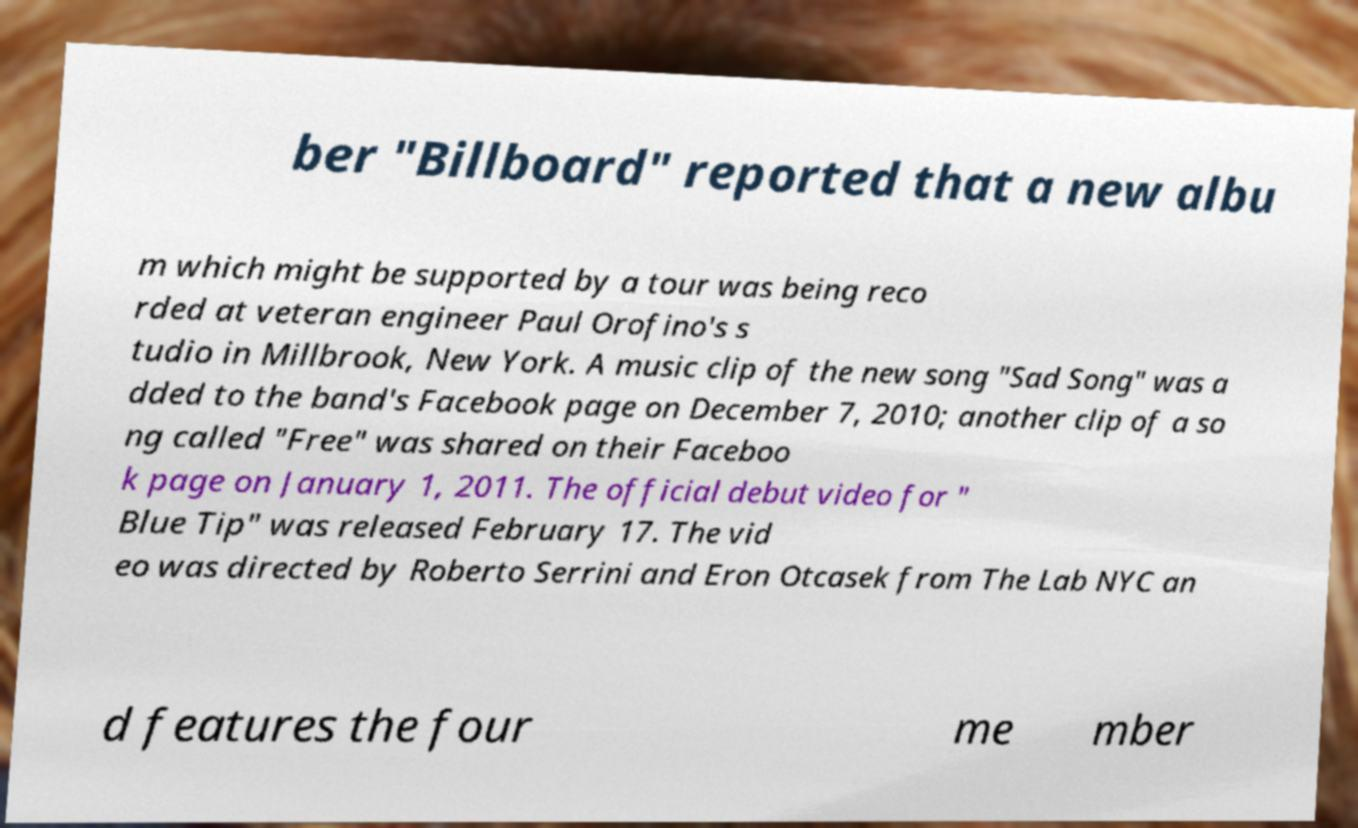What messages or text are displayed in this image? I need them in a readable, typed format. ber "Billboard" reported that a new albu m which might be supported by a tour was being reco rded at veteran engineer Paul Orofino's s tudio in Millbrook, New York. A music clip of the new song "Sad Song" was a dded to the band's Facebook page on December 7, 2010; another clip of a so ng called "Free" was shared on their Faceboo k page on January 1, 2011. The official debut video for " Blue Tip" was released February 17. The vid eo was directed by Roberto Serrini and Eron Otcasek from The Lab NYC an d features the four me mber 